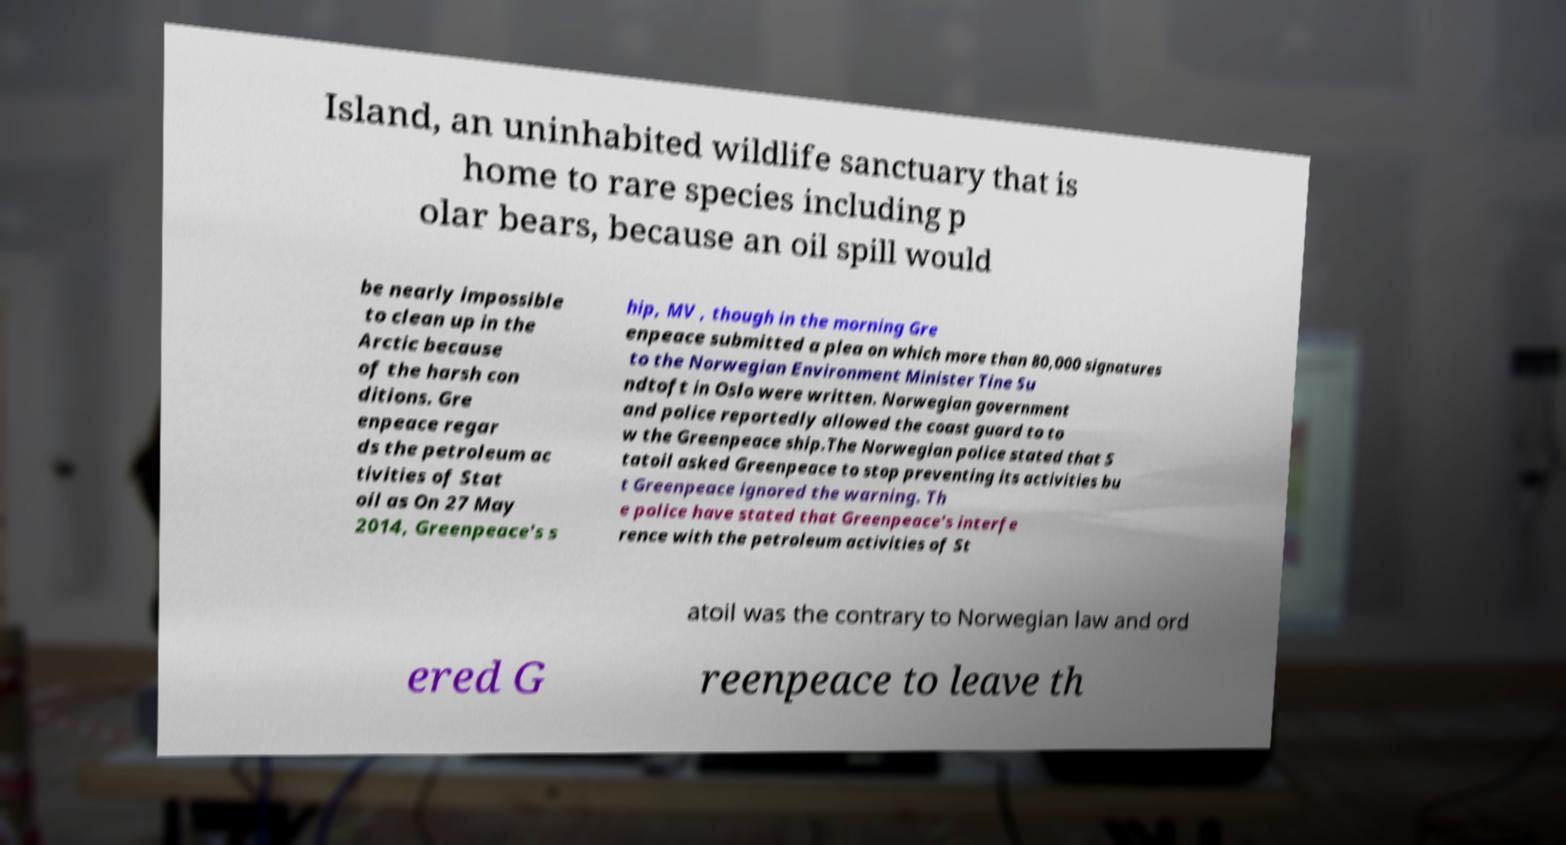For documentation purposes, I need the text within this image transcribed. Could you provide that? Island, an uninhabited wildlife sanctuary that is home to rare species including p olar bears, because an oil spill would be nearly impossible to clean up in the Arctic because of the harsh con ditions. Gre enpeace regar ds the petroleum ac tivities of Stat oil as On 27 May 2014, Greenpeace's s hip, MV , though in the morning Gre enpeace submitted a plea on which more than 80,000 signatures to the Norwegian Environment Minister Tine Su ndtoft in Oslo were written. Norwegian government and police reportedly allowed the coast guard to to w the Greenpeace ship.The Norwegian police stated that S tatoil asked Greenpeace to stop preventing its activities bu t Greenpeace ignored the warning. Th e police have stated that Greenpeace's interfe rence with the petroleum activities of St atoil was the contrary to Norwegian law and ord ered G reenpeace to leave th 